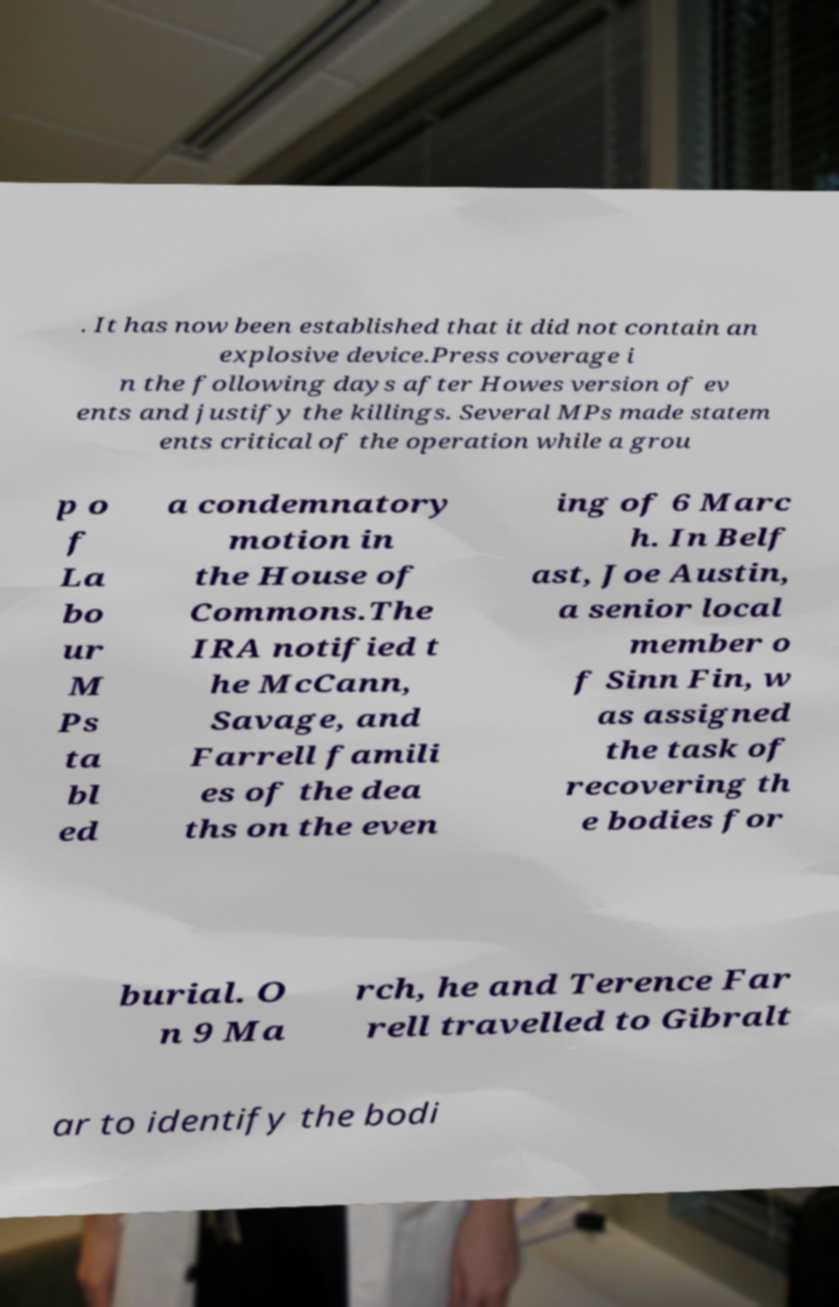Could you extract and type out the text from this image? . It has now been established that it did not contain an explosive device.Press coverage i n the following days after Howes version of ev ents and justify the killings. Several MPs made statem ents critical of the operation while a grou p o f La bo ur M Ps ta bl ed a condemnatory motion in the House of Commons.The IRA notified t he McCann, Savage, and Farrell famili es of the dea ths on the even ing of 6 Marc h. In Belf ast, Joe Austin, a senior local member o f Sinn Fin, w as assigned the task of recovering th e bodies for burial. O n 9 Ma rch, he and Terence Far rell travelled to Gibralt ar to identify the bodi 